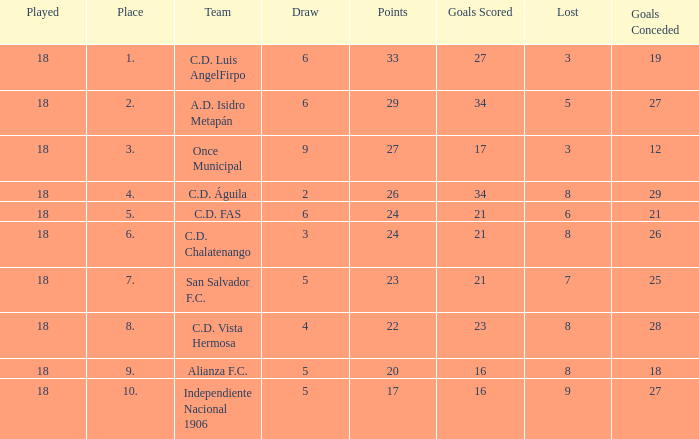What are the number of goals conceded that has a played greater than 18? 0.0. 